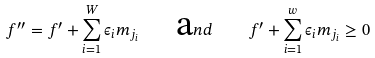<formula> <loc_0><loc_0><loc_500><loc_500>f ^ { \prime \prime } = f ^ { \prime } + \sum _ { i = 1 } ^ { W } \epsilon _ { i } m _ { j _ { i } } \quad { \mbox a n d } \quad f ^ { \prime } + \sum _ { i = 1 } ^ { w } \epsilon _ { i } m _ { j _ { i } } \geq 0</formula> 